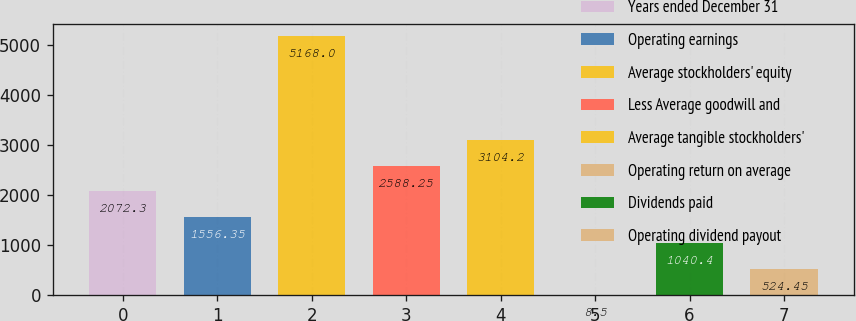Convert chart to OTSL. <chart><loc_0><loc_0><loc_500><loc_500><bar_chart><fcel>Years ended December 31<fcel>Operating earnings<fcel>Average stockholders' equity<fcel>Less Average goodwill and<fcel>Average tangible stockholders'<fcel>Operating return on average<fcel>Dividends paid<fcel>Operating dividend payout<nl><fcel>2072.3<fcel>1556.35<fcel>5168<fcel>2588.25<fcel>3104.2<fcel>8.5<fcel>1040.4<fcel>524.45<nl></chart> 